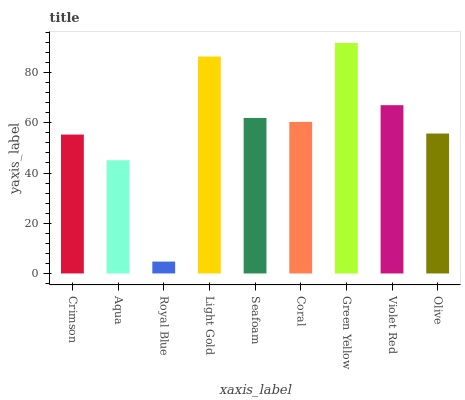Is Royal Blue the minimum?
Answer yes or no. Yes. Is Green Yellow the maximum?
Answer yes or no. Yes. Is Aqua the minimum?
Answer yes or no. No. Is Aqua the maximum?
Answer yes or no. No. Is Crimson greater than Aqua?
Answer yes or no. Yes. Is Aqua less than Crimson?
Answer yes or no. Yes. Is Aqua greater than Crimson?
Answer yes or no. No. Is Crimson less than Aqua?
Answer yes or no. No. Is Coral the high median?
Answer yes or no. Yes. Is Coral the low median?
Answer yes or no. Yes. Is Green Yellow the high median?
Answer yes or no. No. Is Light Gold the low median?
Answer yes or no. No. 